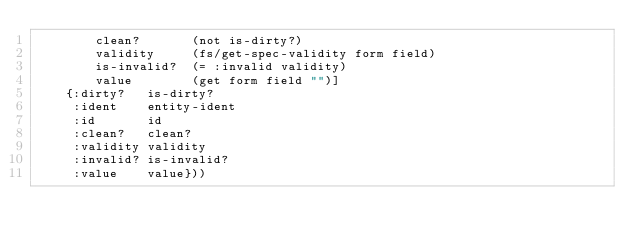<code> <loc_0><loc_0><loc_500><loc_500><_Clojure_>        clean?       (not is-dirty?)
        validity     (fs/get-spec-validity form field)
        is-invalid?  (= :invalid validity)
        value        (get form field "")]
    {:dirty?   is-dirty?
     :ident    entity-ident
     :id       id
     :clean?   clean?
     :validity validity
     :invalid? is-invalid?
     :value    value}))
</code> 